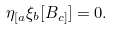Convert formula to latex. <formula><loc_0><loc_0><loc_500><loc_500>\eta _ { [ a } \xi _ { b } [ B _ { c ] } ] = 0 .</formula> 